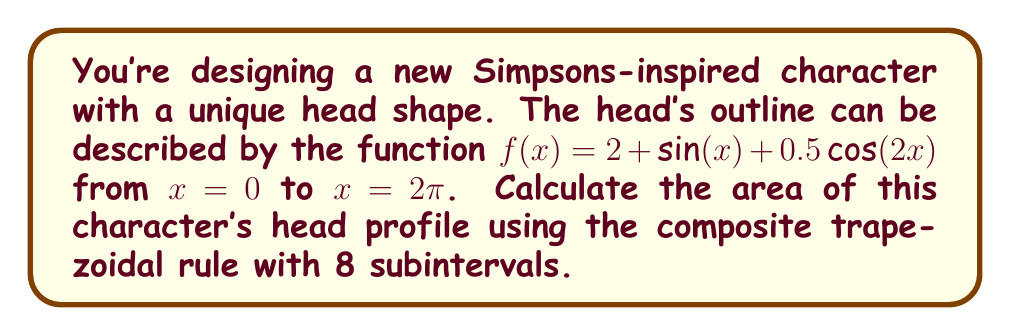Show me your answer to this math problem. To solve this problem, we'll use the composite trapezoidal rule for numerical integration. The formula for the composite trapezoidal rule is:

$$ \int_{a}^{b} f(x) dx \approx \frac{h}{2} [f(x_0) + 2f(x_1) + 2f(x_2) + ... + 2f(x_{n-1}) + f(x_n)] $$

Where $h = \frac{b-a}{n}$, $n$ is the number of subintervals, and $x_i = a + ih$ for $i = 0, 1, ..., n$.

Given:
- $f(x) = 2 + \sin(x) + 0.5\cos(2x)$
- $a = 0$, $b = 2\pi$
- $n = 8$ subintervals

Step 1: Calculate $h$
$h = \frac{b-a}{n} = \frac{2\pi - 0}{8} = \frac{\pi}{4}$

Step 2: Calculate $x_i$ values
$x_0 = 0$
$x_1 = \frac{\pi}{4}$
$x_2 = \frac{\pi}{2}$
$x_3 = \frac{3\pi}{4}$
$x_4 = \pi$
$x_5 = \frac{5\pi}{4}$
$x_6 = \frac{3\pi}{2}$
$x_7 = \frac{7\pi}{4}$
$x_8 = 2\pi$

Step 3: Calculate $f(x_i)$ values
$f(x_0) = f(0) = 2 + \sin(0) + 0.5\cos(0) = 2.5$
$f(x_1) = f(\frac{\pi}{4}) = 2 + \sin(\frac{\pi}{4}) + 0.5\cos(\frac{\pi}{2}) = 2 + \frac{\sqrt{2}}{2} = 2.7071$
$f(x_2) = f(\frac{\pi}{2}) = 2 + \sin(\frac{\pi}{2}) + 0.5\cos(\pi) = 2 + 1 - 0.5 = 2.5$
$f(x_3) = f(\frac{3\pi}{4}) = 2 + \sin(\frac{3\pi}{4}) + 0.5\cos(\frac{3\pi}{2}) = 2 + \frac{\sqrt{2}}{2} = 2.7071$
$f(x_4) = f(\pi) = 2 + \sin(\pi) + 0.5\cos(2\pi) = 2 + 0 + 0.5 = 2.5$
$f(x_5) = f(\frac{5\pi}{4}) = 2 + \sin(\frac{5\pi}{4}) + 0.5\cos(\frac{5\pi}{2}) = 2 - \frac{\sqrt{2}}{2} = 1.2929$
$f(x_6) = f(\frac{3\pi}{2}) = 2 + \sin(\frac{3\pi}{2}) + 0.5\cos(3\pi) = 2 - 1 - 0.5 = 0.5$
$f(x_7) = f(\frac{7\pi}{4}) = 2 + \sin(\frac{7\pi}{4}) + 0.5\cos(\frac{7\pi}{2}) = 2 - \frac{\sqrt{2}}{2} = 1.2929$
$f(x_8) = f(2\pi) = 2 + \sin(2\pi) + 0.5\cos(4\pi) = 2.5$

Step 4: Apply the composite trapezoidal rule
$$ \text{Area} \approx \frac{\pi}{8} [2.5 + 2(2.7071 + 2.5 + 2.7071 + 2.5 + 1.2929 + 0.5 + 1.2929) + 2.5] $$
$$ = \frac{\pi}{8} [2.5 + 2(13.5) + 2.5] $$
$$ = \frac{\pi}{8} [32] $$
$$ = 4\pi $$

Therefore, the approximate area of the character's head profile is $4\pi$ square units.
Answer: $4\pi$ square units 